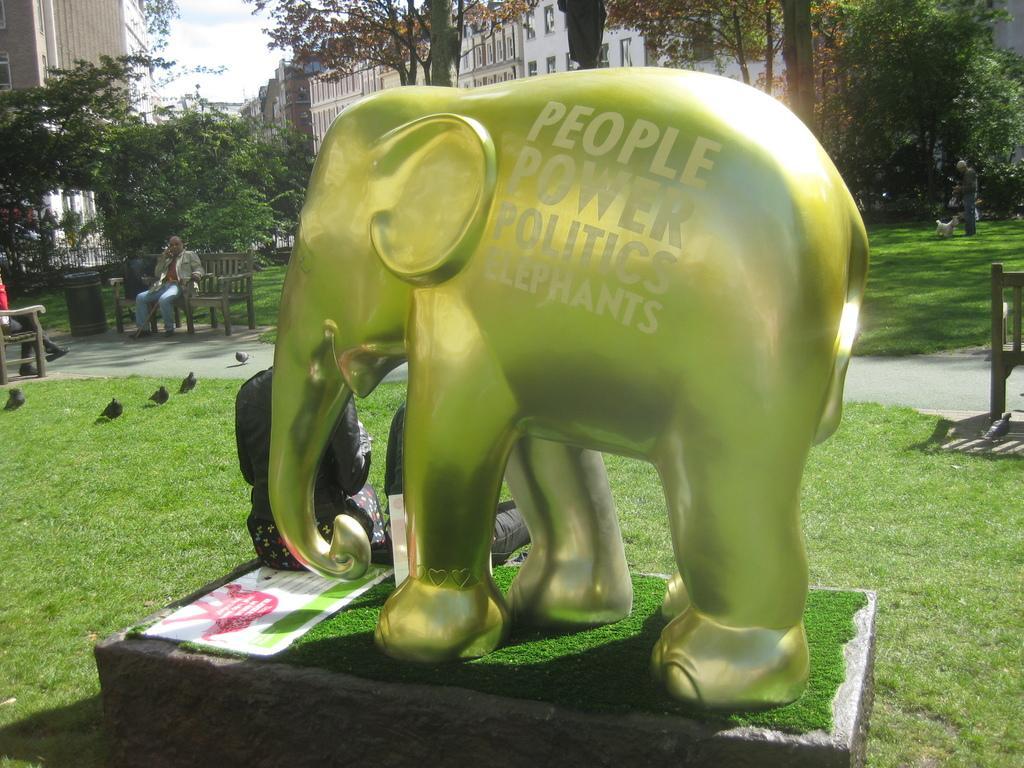Describe this image in one or two sentences. In this image I can see the statue of an elephant which is in green color. To the side I can see two people. I can also see the birds on the grass. To the left there are people sitting on the benches. To the right I can see the person standing with the dog. In the background there are many trees, buildings with windows and the sky. 